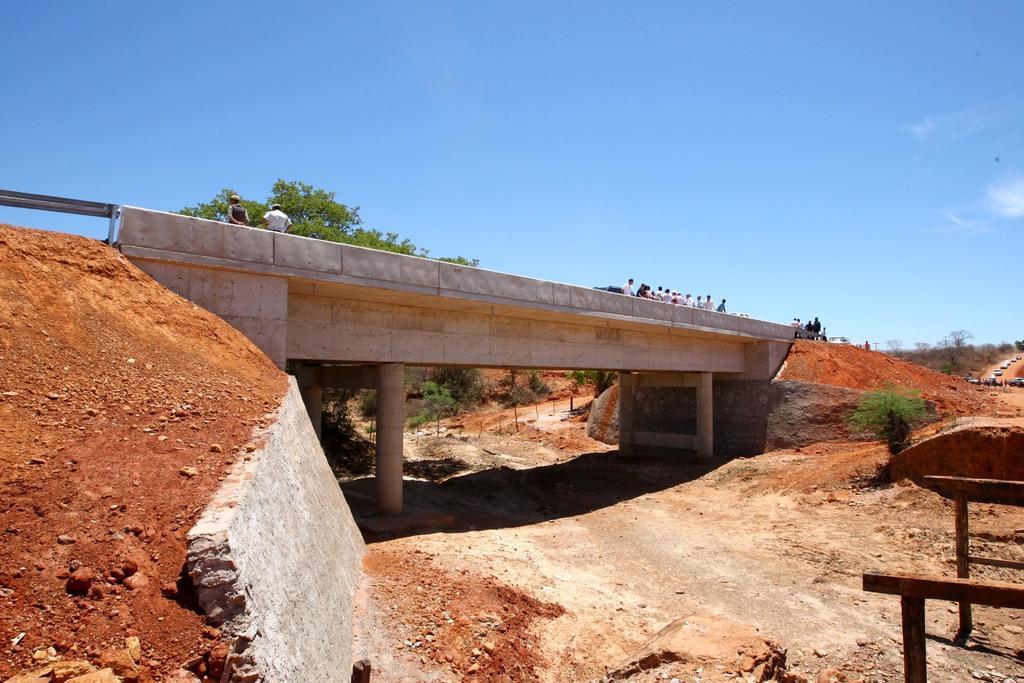Please provide a concise description of this image. In the foreground I can see a bridge, group of people and fleets of cars on the road. In the background I can see trees and the sky. This image is taken during a sunny day. 